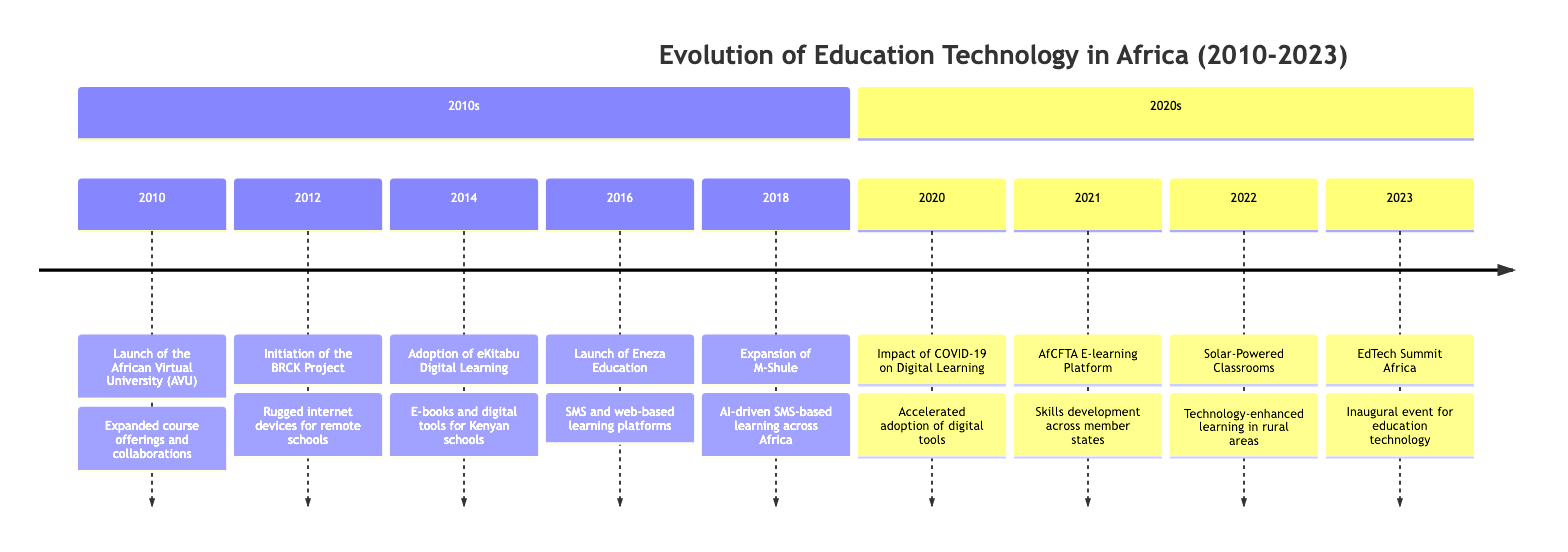What year was the African Virtual University launched? The timeline shows that the African Virtual University was launched in 2010, as indicated in the first event listed under the 2010s section.
Answer: 2010 How many major innovations occurred in the 2010s? By counting the listed events from 2010 to 2018, there are five major innovations that took place in that decade.
Answer: 5 What was the primary focus of the Eneza Education launch? The description states that Eneza Education offered SMS and web-based learning platforms, specifically focusing on providing affordable educational content for underserved communities.
Answer: Affordable educational content Which event highlights the impact of COVID-19 on education? The event labeled "Impact of COVID-19 on Digital Learning" from 2020 emphasizes the acceleration of digital tool adoption in African schools due to the pandemic.
Answer: Impact of COVID-19 on Digital Learning What is the purpose of the AfCFTA E-learning Platform? The AfCFTA E-learning Platform introduced in 2021 focuses on enhancing skills development and facilitating knowledge exchange among member states.
Answer: Skills development and knowledge exchange Which event represents a technological innovation in rural education? The implementation of Solar-Powered Classrooms in 2022 is mentioned as a technological innovation aimed at increasing access to technology-enhanced learning in rural areas.
Answer: Solar-Powered Classrooms How many events are described in the 2020s section? There are five events listed in the 2020s section, from the Impact of COVID-19 in 2020 to the EdTech Summit Africa in 2023.
Answer: 5 What type of educational tools did eKitabu provide? eKitabu provided e-books and digital learning tools to Kenyan schools, which significantly improved access to educational materials.
Answer: E-books and digital learning tools What was a key feature of M-Shule's expansion in 2018? M-Shule expanded its AI-driven SMS-based learning, which helped students improve literacy and numeracy across various African countries.
Answer: AI-driven SMS-based learning 